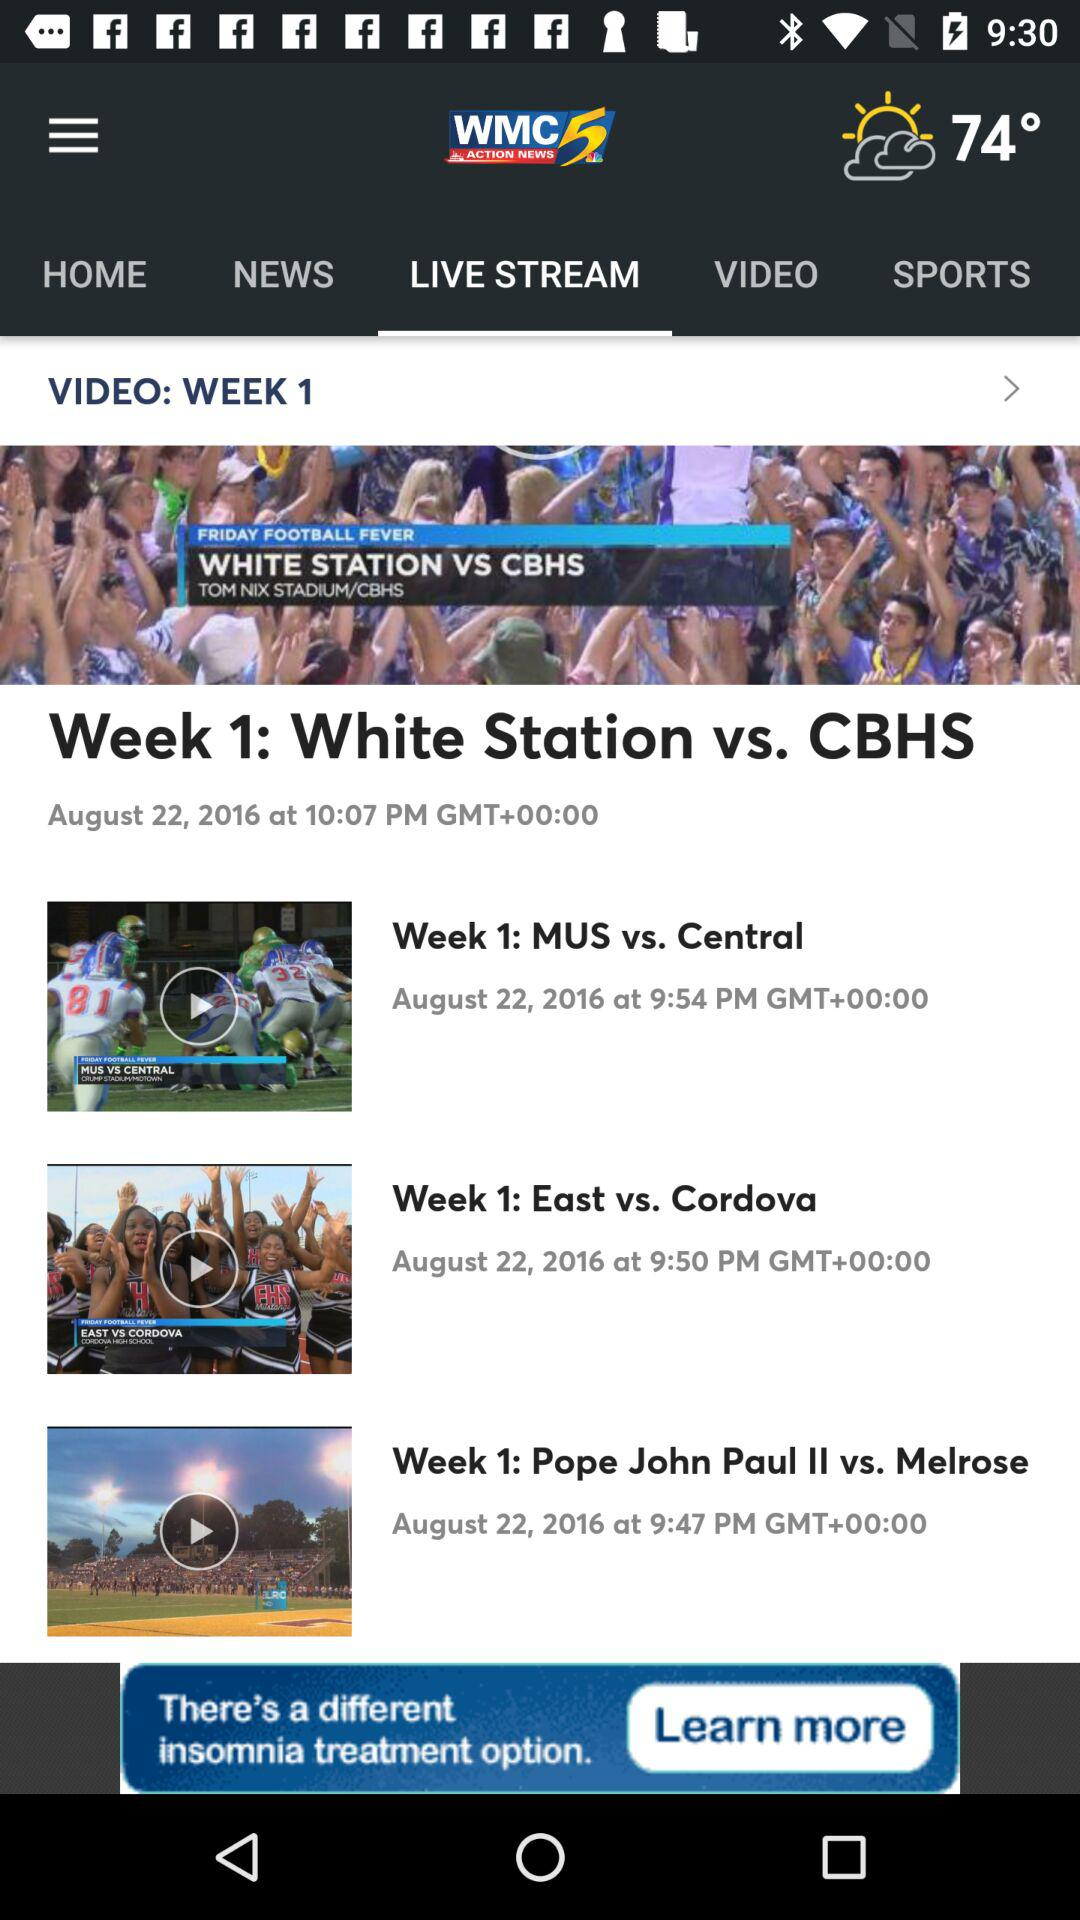What is the displayed temperature? The displayed temperature is 74°. 